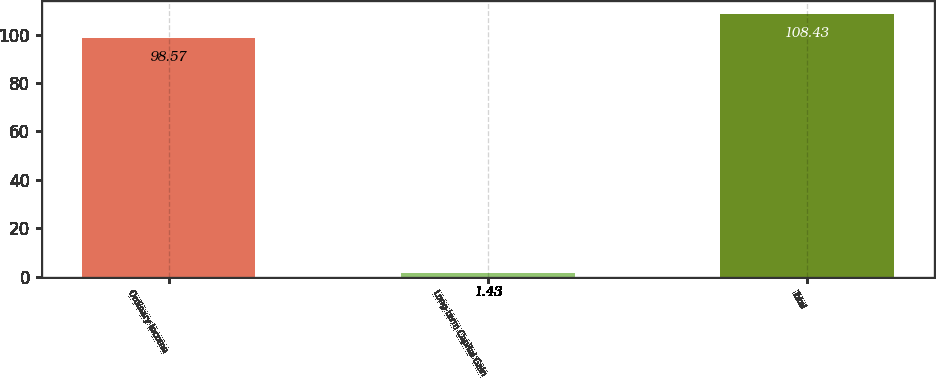Convert chart. <chart><loc_0><loc_0><loc_500><loc_500><bar_chart><fcel>Ordinary Income<fcel>Long-term Capital Gain<fcel>Total<nl><fcel>98.57<fcel>1.43<fcel>108.43<nl></chart> 